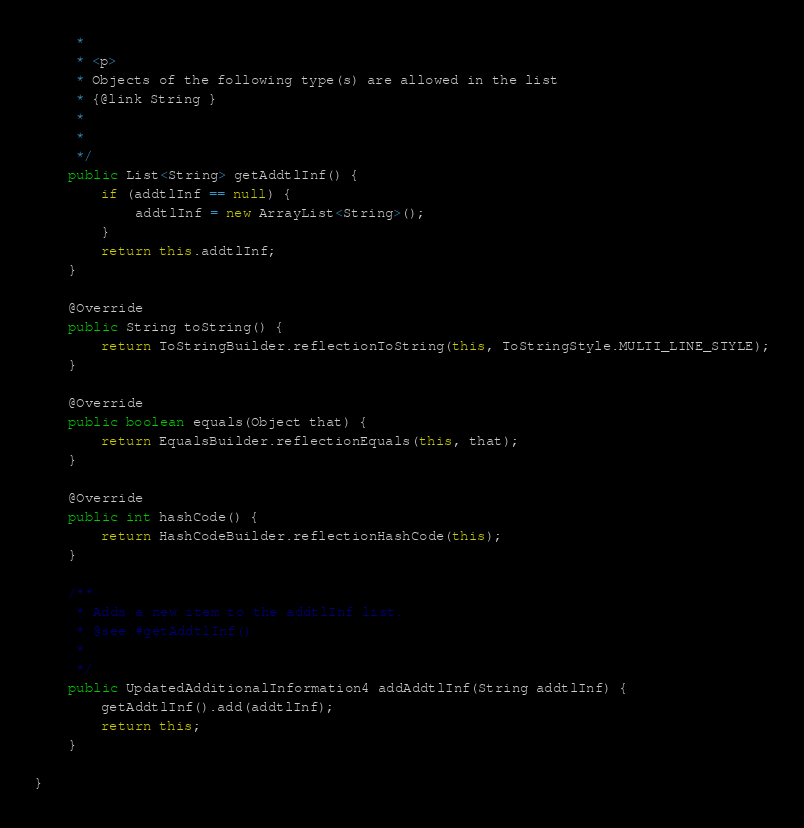<code> <loc_0><loc_0><loc_500><loc_500><_Java_>     * 
     * <p>
     * Objects of the following type(s) are allowed in the list
     * {@link String }
     * 
     * 
     */
    public List<String> getAddtlInf() {
        if (addtlInf == null) {
            addtlInf = new ArrayList<String>();
        }
        return this.addtlInf;
    }

    @Override
    public String toString() {
        return ToStringBuilder.reflectionToString(this, ToStringStyle.MULTI_LINE_STYLE);
    }

    @Override
    public boolean equals(Object that) {
        return EqualsBuilder.reflectionEquals(this, that);
    }

    @Override
    public int hashCode() {
        return HashCodeBuilder.reflectionHashCode(this);
    }

    /**
     * Adds a new item to the addtlInf list.
     * @see #getAddtlInf()
     * 
     */
    public UpdatedAdditionalInformation4 addAddtlInf(String addtlInf) {
        getAddtlInf().add(addtlInf);
        return this;
    }

}
</code> 